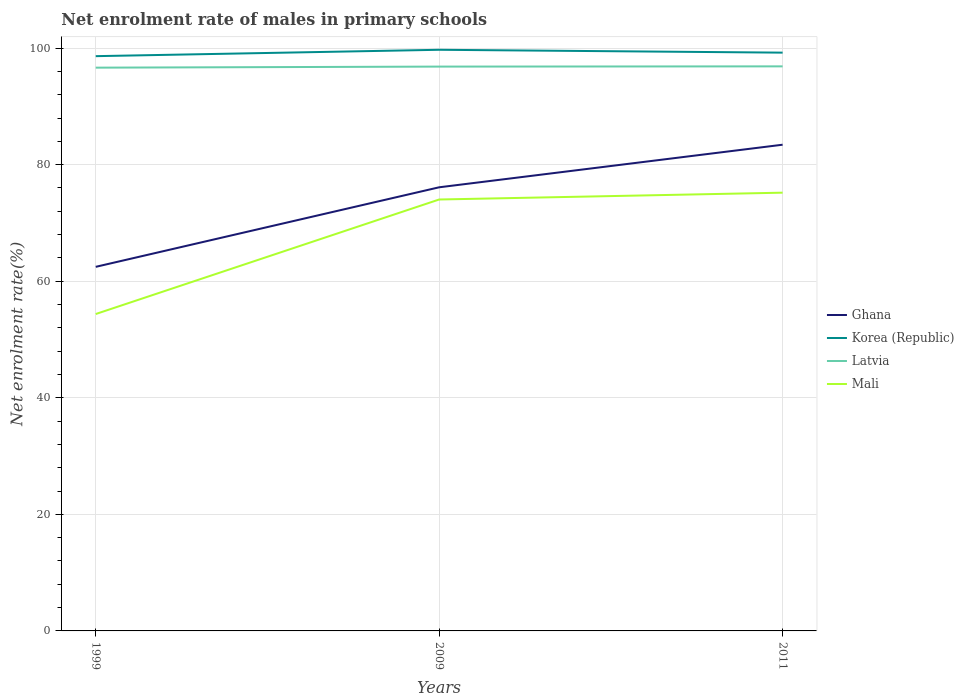Across all years, what is the maximum net enrolment rate of males in primary schools in Korea (Republic)?
Keep it short and to the point. 98.61. What is the total net enrolment rate of males in primary schools in Korea (Republic) in the graph?
Keep it short and to the point. -0.6. What is the difference between the highest and the second highest net enrolment rate of males in primary schools in Latvia?
Offer a terse response. 0.22. Is the net enrolment rate of males in primary schools in Ghana strictly greater than the net enrolment rate of males in primary schools in Latvia over the years?
Keep it short and to the point. Yes. How many lines are there?
Your response must be concise. 4. How many years are there in the graph?
Offer a very short reply. 3. Are the values on the major ticks of Y-axis written in scientific E-notation?
Ensure brevity in your answer.  No. Where does the legend appear in the graph?
Your answer should be very brief. Center right. How many legend labels are there?
Provide a succinct answer. 4. How are the legend labels stacked?
Offer a very short reply. Vertical. What is the title of the graph?
Offer a terse response. Net enrolment rate of males in primary schools. Does "Panama" appear as one of the legend labels in the graph?
Make the answer very short. No. What is the label or title of the Y-axis?
Offer a terse response. Net enrolment rate(%). What is the Net enrolment rate(%) in Ghana in 1999?
Offer a very short reply. 62.47. What is the Net enrolment rate(%) of Korea (Republic) in 1999?
Provide a succinct answer. 98.61. What is the Net enrolment rate(%) of Latvia in 1999?
Offer a terse response. 96.64. What is the Net enrolment rate(%) in Mali in 1999?
Provide a succinct answer. 54.37. What is the Net enrolment rate(%) in Ghana in 2009?
Provide a succinct answer. 76.12. What is the Net enrolment rate(%) in Korea (Republic) in 2009?
Make the answer very short. 99.71. What is the Net enrolment rate(%) in Latvia in 2009?
Offer a very short reply. 96.82. What is the Net enrolment rate(%) of Mali in 2009?
Keep it short and to the point. 74.02. What is the Net enrolment rate(%) in Ghana in 2011?
Your response must be concise. 83.42. What is the Net enrolment rate(%) in Korea (Republic) in 2011?
Your answer should be compact. 99.22. What is the Net enrolment rate(%) in Latvia in 2011?
Give a very brief answer. 96.86. What is the Net enrolment rate(%) in Mali in 2011?
Provide a short and direct response. 75.19. Across all years, what is the maximum Net enrolment rate(%) of Ghana?
Ensure brevity in your answer.  83.42. Across all years, what is the maximum Net enrolment rate(%) in Korea (Republic)?
Your answer should be compact. 99.71. Across all years, what is the maximum Net enrolment rate(%) in Latvia?
Provide a short and direct response. 96.86. Across all years, what is the maximum Net enrolment rate(%) of Mali?
Keep it short and to the point. 75.19. Across all years, what is the minimum Net enrolment rate(%) of Ghana?
Offer a terse response. 62.47. Across all years, what is the minimum Net enrolment rate(%) of Korea (Republic)?
Offer a terse response. 98.61. Across all years, what is the minimum Net enrolment rate(%) in Latvia?
Provide a short and direct response. 96.64. Across all years, what is the minimum Net enrolment rate(%) of Mali?
Your answer should be compact. 54.37. What is the total Net enrolment rate(%) of Ghana in the graph?
Make the answer very short. 222. What is the total Net enrolment rate(%) of Korea (Republic) in the graph?
Your answer should be compact. 297.54. What is the total Net enrolment rate(%) of Latvia in the graph?
Provide a succinct answer. 290.33. What is the total Net enrolment rate(%) of Mali in the graph?
Make the answer very short. 203.59. What is the difference between the Net enrolment rate(%) in Ghana in 1999 and that in 2009?
Your answer should be compact. -13.65. What is the difference between the Net enrolment rate(%) in Korea (Republic) in 1999 and that in 2009?
Make the answer very short. -1.09. What is the difference between the Net enrolment rate(%) of Latvia in 1999 and that in 2009?
Make the answer very short. -0.18. What is the difference between the Net enrolment rate(%) of Mali in 1999 and that in 2009?
Make the answer very short. -19.65. What is the difference between the Net enrolment rate(%) in Ghana in 1999 and that in 2011?
Keep it short and to the point. -20.95. What is the difference between the Net enrolment rate(%) in Korea (Republic) in 1999 and that in 2011?
Your response must be concise. -0.6. What is the difference between the Net enrolment rate(%) in Latvia in 1999 and that in 2011?
Make the answer very short. -0.22. What is the difference between the Net enrolment rate(%) of Mali in 1999 and that in 2011?
Offer a terse response. -20.82. What is the difference between the Net enrolment rate(%) of Ghana in 2009 and that in 2011?
Offer a terse response. -7.3. What is the difference between the Net enrolment rate(%) in Korea (Republic) in 2009 and that in 2011?
Your answer should be very brief. 0.49. What is the difference between the Net enrolment rate(%) of Latvia in 2009 and that in 2011?
Give a very brief answer. -0.04. What is the difference between the Net enrolment rate(%) of Mali in 2009 and that in 2011?
Ensure brevity in your answer.  -1.17. What is the difference between the Net enrolment rate(%) of Ghana in 1999 and the Net enrolment rate(%) of Korea (Republic) in 2009?
Offer a terse response. -37.24. What is the difference between the Net enrolment rate(%) of Ghana in 1999 and the Net enrolment rate(%) of Latvia in 2009?
Provide a succinct answer. -34.36. What is the difference between the Net enrolment rate(%) in Ghana in 1999 and the Net enrolment rate(%) in Mali in 2009?
Your answer should be compact. -11.55. What is the difference between the Net enrolment rate(%) of Korea (Republic) in 1999 and the Net enrolment rate(%) of Latvia in 2009?
Offer a very short reply. 1.79. What is the difference between the Net enrolment rate(%) in Korea (Republic) in 1999 and the Net enrolment rate(%) in Mali in 2009?
Offer a terse response. 24.59. What is the difference between the Net enrolment rate(%) in Latvia in 1999 and the Net enrolment rate(%) in Mali in 2009?
Your answer should be very brief. 22.62. What is the difference between the Net enrolment rate(%) of Ghana in 1999 and the Net enrolment rate(%) of Korea (Republic) in 2011?
Ensure brevity in your answer.  -36.75. What is the difference between the Net enrolment rate(%) of Ghana in 1999 and the Net enrolment rate(%) of Latvia in 2011?
Make the answer very short. -34.4. What is the difference between the Net enrolment rate(%) of Ghana in 1999 and the Net enrolment rate(%) of Mali in 2011?
Provide a short and direct response. -12.72. What is the difference between the Net enrolment rate(%) of Korea (Republic) in 1999 and the Net enrolment rate(%) of Latvia in 2011?
Your answer should be very brief. 1.75. What is the difference between the Net enrolment rate(%) of Korea (Republic) in 1999 and the Net enrolment rate(%) of Mali in 2011?
Your answer should be very brief. 23.42. What is the difference between the Net enrolment rate(%) in Latvia in 1999 and the Net enrolment rate(%) in Mali in 2011?
Keep it short and to the point. 21.45. What is the difference between the Net enrolment rate(%) in Ghana in 2009 and the Net enrolment rate(%) in Korea (Republic) in 2011?
Ensure brevity in your answer.  -23.1. What is the difference between the Net enrolment rate(%) of Ghana in 2009 and the Net enrolment rate(%) of Latvia in 2011?
Keep it short and to the point. -20.75. What is the difference between the Net enrolment rate(%) in Ghana in 2009 and the Net enrolment rate(%) in Mali in 2011?
Provide a succinct answer. 0.92. What is the difference between the Net enrolment rate(%) in Korea (Republic) in 2009 and the Net enrolment rate(%) in Latvia in 2011?
Your response must be concise. 2.84. What is the difference between the Net enrolment rate(%) of Korea (Republic) in 2009 and the Net enrolment rate(%) of Mali in 2011?
Your answer should be compact. 24.52. What is the difference between the Net enrolment rate(%) in Latvia in 2009 and the Net enrolment rate(%) in Mali in 2011?
Give a very brief answer. 21.63. What is the average Net enrolment rate(%) in Ghana per year?
Provide a succinct answer. 74. What is the average Net enrolment rate(%) in Korea (Republic) per year?
Make the answer very short. 99.18. What is the average Net enrolment rate(%) in Latvia per year?
Provide a short and direct response. 96.78. What is the average Net enrolment rate(%) in Mali per year?
Your response must be concise. 67.86. In the year 1999, what is the difference between the Net enrolment rate(%) of Ghana and Net enrolment rate(%) of Korea (Republic)?
Make the answer very short. -36.15. In the year 1999, what is the difference between the Net enrolment rate(%) of Ghana and Net enrolment rate(%) of Latvia?
Offer a very short reply. -34.17. In the year 1999, what is the difference between the Net enrolment rate(%) in Ghana and Net enrolment rate(%) in Mali?
Offer a very short reply. 8.1. In the year 1999, what is the difference between the Net enrolment rate(%) in Korea (Republic) and Net enrolment rate(%) in Latvia?
Ensure brevity in your answer.  1.97. In the year 1999, what is the difference between the Net enrolment rate(%) of Korea (Republic) and Net enrolment rate(%) of Mali?
Provide a short and direct response. 44.24. In the year 1999, what is the difference between the Net enrolment rate(%) of Latvia and Net enrolment rate(%) of Mali?
Make the answer very short. 42.27. In the year 2009, what is the difference between the Net enrolment rate(%) of Ghana and Net enrolment rate(%) of Korea (Republic)?
Your answer should be compact. -23.59. In the year 2009, what is the difference between the Net enrolment rate(%) in Ghana and Net enrolment rate(%) in Latvia?
Provide a succinct answer. -20.71. In the year 2009, what is the difference between the Net enrolment rate(%) in Ghana and Net enrolment rate(%) in Mali?
Provide a short and direct response. 2.09. In the year 2009, what is the difference between the Net enrolment rate(%) of Korea (Republic) and Net enrolment rate(%) of Latvia?
Ensure brevity in your answer.  2.88. In the year 2009, what is the difference between the Net enrolment rate(%) in Korea (Republic) and Net enrolment rate(%) in Mali?
Provide a succinct answer. 25.69. In the year 2009, what is the difference between the Net enrolment rate(%) of Latvia and Net enrolment rate(%) of Mali?
Provide a short and direct response. 22.8. In the year 2011, what is the difference between the Net enrolment rate(%) of Ghana and Net enrolment rate(%) of Korea (Republic)?
Offer a very short reply. -15.8. In the year 2011, what is the difference between the Net enrolment rate(%) of Ghana and Net enrolment rate(%) of Latvia?
Offer a very short reply. -13.44. In the year 2011, what is the difference between the Net enrolment rate(%) of Ghana and Net enrolment rate(%) of Mali?
Give a very brief answer. 8.23. In the year 2011, what is the difference between the Net enrolment rate(%) of Korea (Republic) and Net enrolment rate(%) of Latvia?
Provide a succinct answer. 2.35. In the year 2011, what is the difference between the Net enrolment rate(%) in Korea (Republic) and Net enrolment rate(%) in Mali?
Ensure brevity in your answer.  24.02. In the year 2011, what is the difference between the Net enrolment rate(%) in Latvia and Net enrolment rate(%) in Mali?
Offer a terse response. 21.67. What is the ratio of the Net enrolment rate(%) in Ghana in 1999 to that in 2009?
Your answer should be very brief. 0.82. What is the ratio of the Net enrolment rate(%) of Latvia in 1999 to that in 2009?
Your response must be concise. 1. What is the ratio of the Net enrolment rate(%) in Mali in 1999 to that in 2009?
Keep it short and to the point. 0.73. What is the ratio of the Net enrolment rate(%) of Ghana in 1999 to that in 2011?
Make the answer very short. 0.75. What is the ratio of the Net enrolment rate(%) in Mali in 1999 to that in 2011?
Offer a very short reply. 0.72. What is the ratio of the Net enrolment rate(%) of Ghana in 2009 to that in 2011?
Your answer should be very brief. 0.91. What is the ratio of the Net enrolment rate(%) of Latvia in 2009 to that in 2011?
Provide a succinct answer. 1. What is the ratio of the Net enrolment rate(%) of Mali in 2009 to that in 2011?
Keep it short and to the point. 0.98. What is the difference between the highest and the second highest Net enrolment rate(%) in Ghana?
Your answer should be very brief. 7.3. What is the difference between the highest and the second highest Net enrolment rate(%) in Korea (Republic)?
Give a very brief answer. 0.49. What is the difference between the highest and the second highest Net enrolment rate(%) in Latvia?
Make the answer very short. 0.04. What is the difference between the highest and the second highest Net enrolment rate(%) of Mali?
Offer a very short reply. 1.17. What is the difference between the highest and the lowest Net enrolment rate(%) in Ghana?
Your response must be concise. 20.95. What is the difference between the highest and the lowest Net enrolment rate(%) in Korea (Republic)?
Your response must be concise. 1.09. What is the difference between the highest and the lowest Net enrolment rate(%) in Latvia?
Your response must be concise. 0.22. What is the difference between the highest and the lowest Net enrolment rate(%) in Mali?
Give a very brief answer. 20.82. 